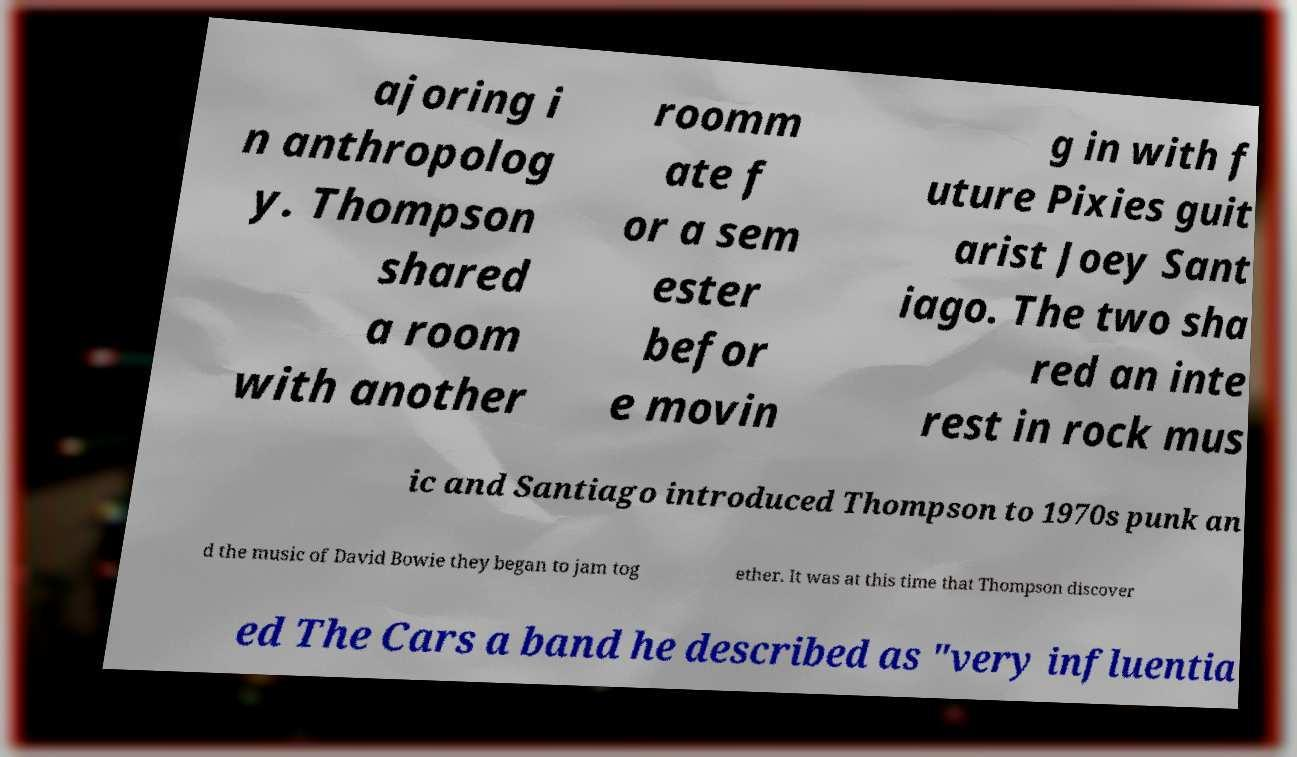I need the written content from this picture converted into text. Can you do that? ajoring i n anthropolog y. Thompson shared a room with another roomm ate f or a sem ester befor e movin g in with f uture Pixies guit arist Joey Sant iago. The two sha red an inte rest in rock mus ic and Santiago introduced Thompson to 1970s punk an d the music of David Bowie they began to jam tog ether. It was at this time that Thompson discover ed The Cars a band he described as "very influentia 